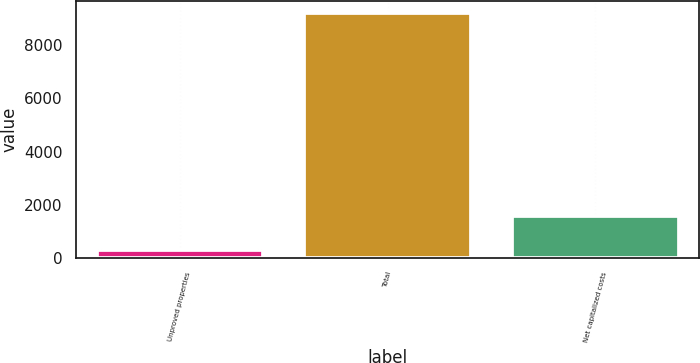Convert chart. <chart><loc_0><loc_0><loc_500><loc_500><bar_chart><fcel>Unproved properties<fcel>Total<fcel>Net capitalized costs<nl><fcel>296<fcel>9194<fcel>1580<nl></chart> 